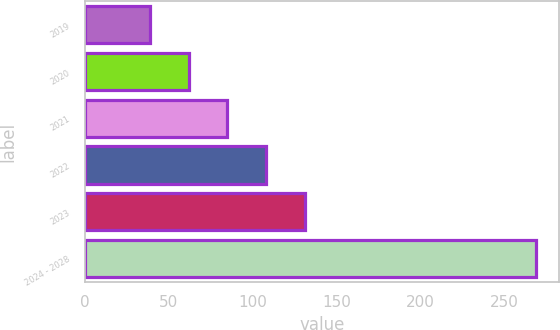<chart> <loc_0><loc_0><loc_500><loc_500><bar_chart><fcel>2019<fcel>2020<fcel>2021<fcel>2022<fcel>2023<fcel>2024 - 2028<nl><fcel>39<fcel>62<fcel>85<fcel>108<fcel>131<fcel>269<nl></chart> 